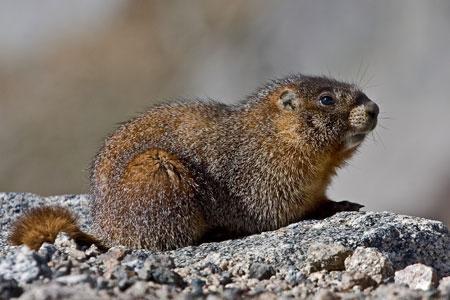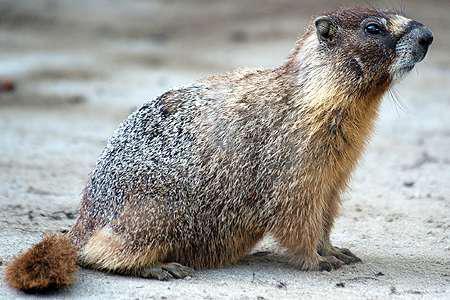The first image is the image on the left, the second image is the image on the right. For the images shown, is this caption "Both marmots are facing toward the right" true? Answer yes or no. Yes. The first image is the image on the left, the second image is the image on the right. For the images displayed, is the sentence "Each image shows just one groundhog-type animal, which is facing rightward." factually correct? Answer yes or no. Yes. 